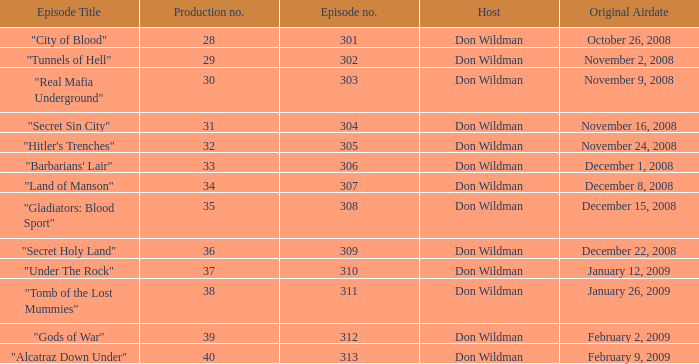What is the episode number of the episode that originally aired on January 26, 2009 and had a production number smaller than 38? 0.0. 